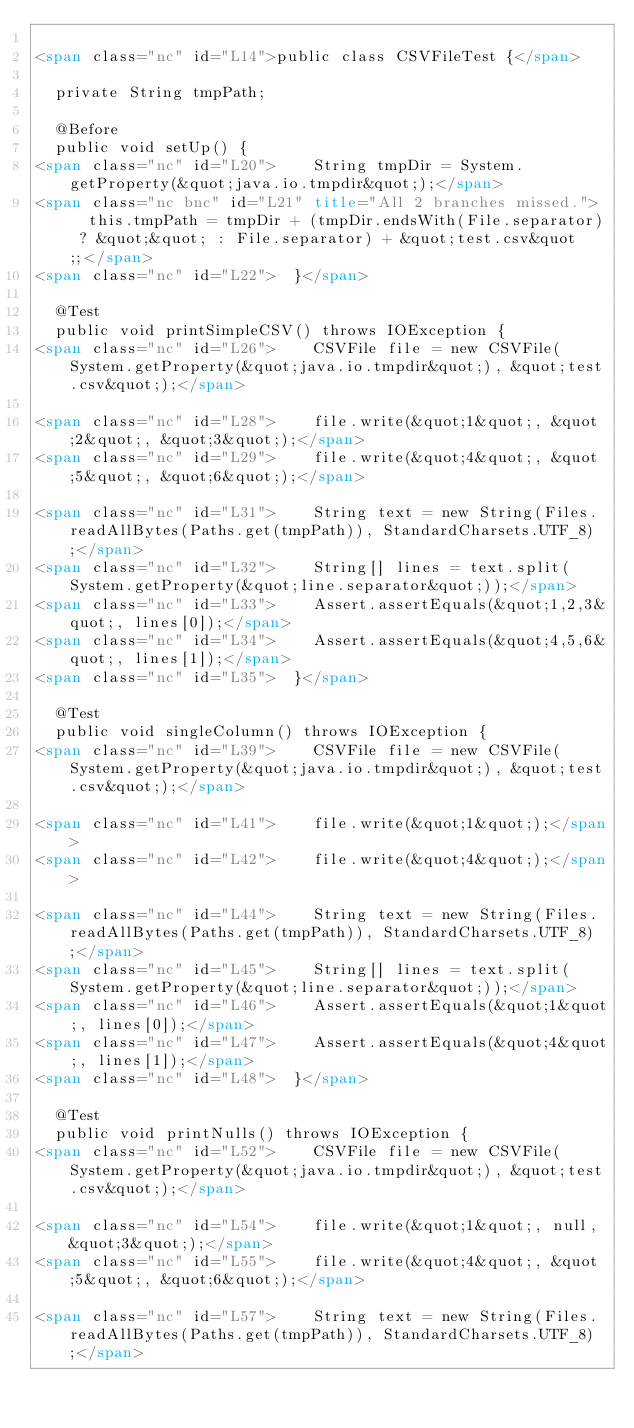<code> <loc_0><loc_0><loc_500><loc_500><_HTML_>
<span class="nc" id="L14">public class CSVFileTest {</span>

	private String tmpPath;

	@Before
	public void setUp() {
<span class="nc" id="L20">		String tmpDir = System.getProperty(&quot;java.io.tmpdir&quot;);</span>
<span class="nc bnc" id="L21" title="All 2 branches missed.">		this.tmpPath = tmpDir + (tmpDir.endsWith(File.separator) ? &quot;&quot; : File.separator) + &quot;test.csv&quot;;</span>
<span class="nc" id="L22">	}</span>
	
	@Test
	public void printSimpleCSV() throws IOException {
<span class="nc" id="L26">		CSVFile file = new CSVFile(System.getProperty(&quot;java.io.tmpdir&quot;), &quot;test.csv&quot;);</span>
		
<span class="nc" id="L28">		file.write(&quot;1&quot;, &quot;2&quot;, &quot;3&quot;);</span>
<span class="nc" id="L29">		file.write(&quot;4&quot;, &quot;5&quot;, &quot;6&quot;);</span>
		
<span class="nc" id="L31">		String text = new String(Files.readAllBytes(Paths.get(tmpPath)), StandardCharsets.UTF_8);</span>
<span class="nc" id="L32">		String[] lines = text.split(System.getProperty(&quot;line.separator&quot;));</span>
<span class="nc" id="L33">		Assert.assertEquals(&quot;1,2,3&quot;, lines[0]);</span>
<span class="nc" id="L34">		Assert.assertEquals(&quot;4,5,6&quot;, lines[1]);</span>
<span class="nc" id="L35">	}</span>

	@Test
	public void singleColumn() throws IOException {
<span class="nc" id="L39">		CSVFile file = new CSVFile(System.getProperty(&quot;java.io.tmpdir&quot;), &quot;test.csv&quot;);</span>
		
<span class="nc" id="L41">		file.write(&quot;1&quot;);</span>
<span class="nc" id="L42">		file.write(&quot;4&quot;);</span>
		
<span class="nc" id="L44">		String text = new String(Files.readAllBytes(Paths.get(tmpPath)), StandardCharsets.UTF_8);</span>
<span class="nc" id="L45">		String[] lines = text.split(System.getProperty(&quot;line.separator&quot;));</span>
<span class="nc" id="L46">		Assert.assertEquals(&quot;1&quot;, lines[0]);</span>
<span class="nc" id="L47">		Assert.assertEquals(&quot;4&quot;, lines[1]);</span>
<span class="nc" id="L48">	}</span>

	@Test
	public void printNulls() throws IOException {
<span class="nc" id="L52">		CSVFile file = new CSVFile(System.getProperty(&quot;java.io.tmpdir&quot;), &quot;test.csv&quot;);</span>
		
<span class="nc" id="L54">		file.write(&quot;1&quot;, null, &quot;3&quot;);</span>
<span class="nc" id="L55">		file.write(&quot;4&quot;, &quot;5&quot;, &quot;6&quot;);</span>
		
<span class="nc" id="L57">		String text = new String(Files.readAllBytes(Paths.get(tmpPath)), StandardCharsets.UTF_8);</span></code> 